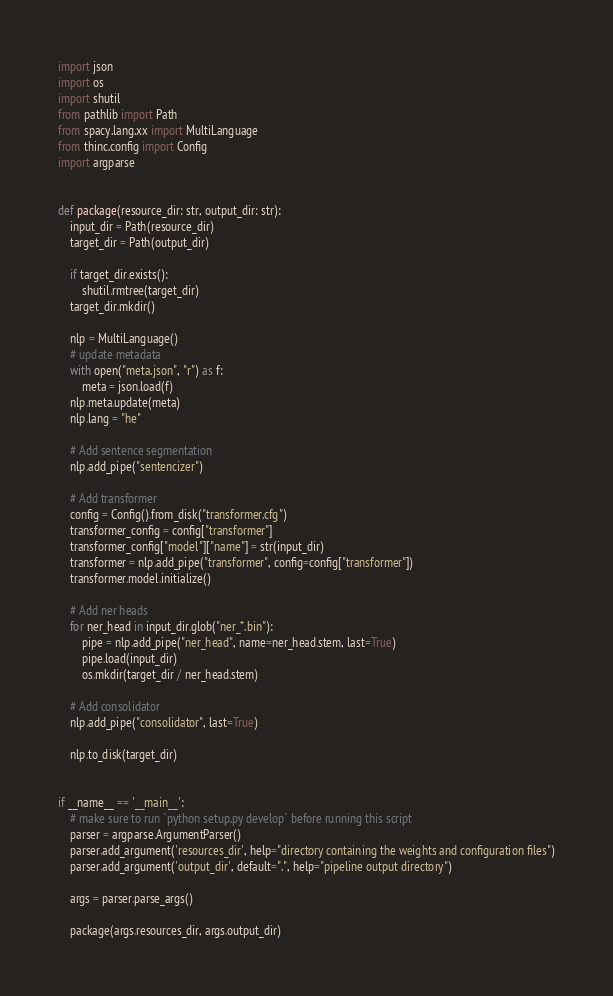<code> <loc_0><loc_0><loc_500><loc_500><_Python_>import json
import os
import shutil
from pathlib import Path
from spacy.lang.xx import MultiLanguage
from thinc.config import Config
import argparse


def package(resource_dir: str, output_dir: str):
    input_dir = Path(resource_dir)
    target_dir = Path(output_dir)

    if target_dir.exists():
        shutil.rmtree(target_dir)
    target_dir.mkdir()

    nlp = MultiLanguage()
    # update metadata
    with open("meta.json", "r") as f:
        meta = json.load(f)
    nlp.meta.update(meta)
    nlp.lang = "he"

    # Add sentence segmentation
    nlp.add_pipe("sentencizer")

    # Add transformer
    config = Config().from_disk("transformer.cfg")
    transformer_config = config["transformer"]
    transformer_config["model"]["name"] = str(input_dir)
    transformer = nlp.add_pipe("transformer", config=config["transformer"])
    transformer.model.initialize()

    # Add ner heads
    for ner_head in input_dir.glob("ner_*.bin"):
        pipe = nlp.add_pipe("ner_head", name=ner_head.stem, last=True)
        pipe.load(input_dir)
        os.mkdir(target_dir / ner_head.stem)

    # Add consolidator
    nlp.add_pipe("consolidator", last=True)

    nlp.to_disk(target_dir)


if __name__ == '__main__':
    # make sure to run `python setup.py develop` before running this script
    parser = argparse.ArgumentParser()
    parser.add_argument('resources_dir', help="directory containing the weights and configuration files")
    parser.add_argument('output_dir', default=".", help="pipeline output directory")

    args = parser.parse_args()

    package(args.resources_dir, args.output_dir)
</code> 